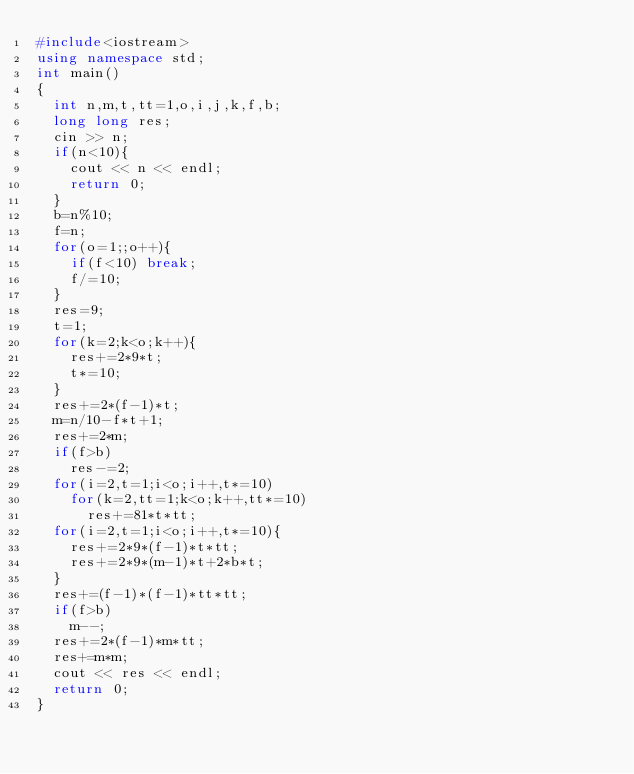<code> <loc_0><loc_0><loc_500><loc_500><_C++_>#include<iostream>
using namespace std;
int main()
{
  int n,m,t,tt=1,o,i,j,k,f,b;
  long long res;
  cin >> n;
  if(n<10){
    cout << n << endl;
    return 0;
  }
  b=n%10;
  f=n;
  for(o=1;;o++){
    if(f<10) break;
    f/=10;
  }
  res=9;
  t=1;
  for(k=2;k<o;k++){
    res+=2*9*t;
    t*=10;
  }
  res+=2*(f-1)*t;
  m=n/10-f*t+1;
  res+=2*m;
  if(f>b)
    res-=2;
  for(i=2,t=1;i<o;i++,t*=10)
    for(k=2,tt=1;k<o;k++,tt*=10)
      res+=81*t*tt;
  for(i=2,t=1;i<o;i++,t*=10){
    res+=2*9*(f-1)*t*tt;
    res+=2*9*(m-1)*t+2*b*t;
  }
  res+=(f-1)*(f-1)*tt*tt;
  if(f>b)
    m--;
  res+=2*(f-1)*m*tt;
  res+=m*m;
  cout << res << endl;
  return 0;
}</code> 